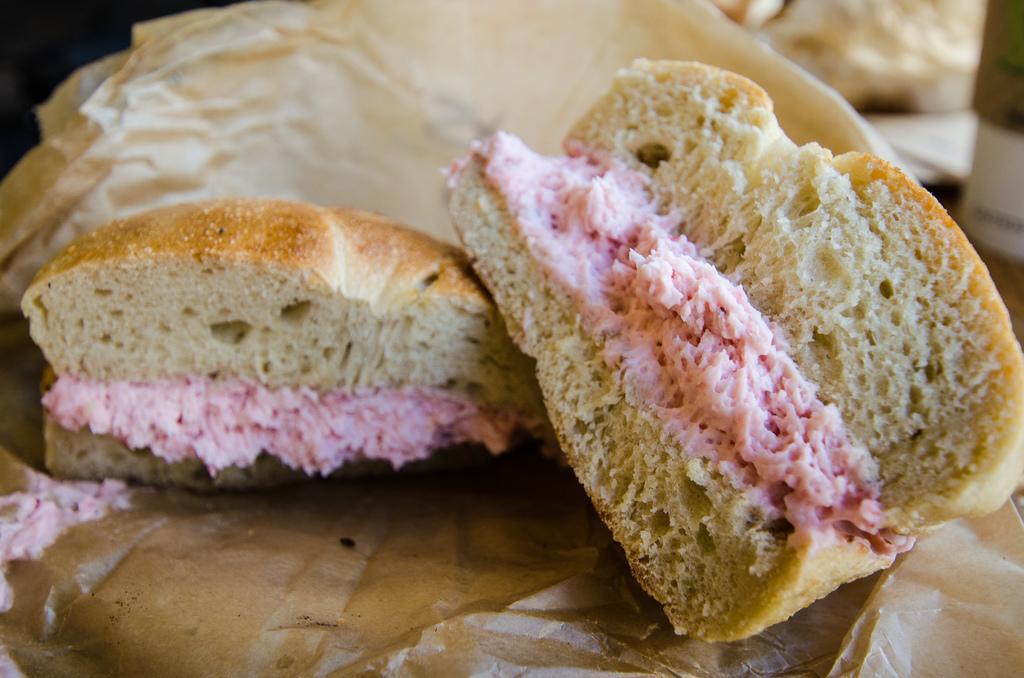Can you describe this image briefly? In this image, we can see sandwich bites. 